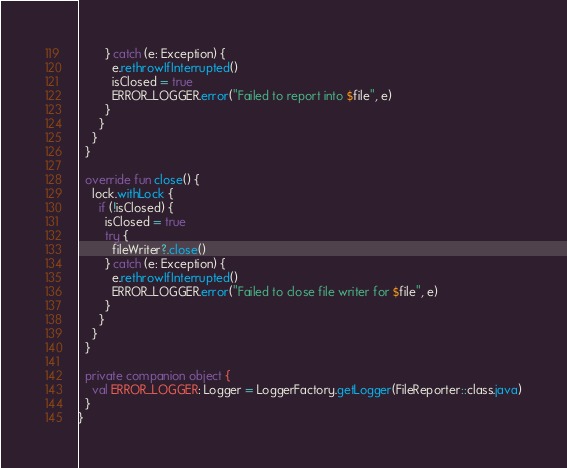<code> <loc_0><loc_0><loc_500><loc_500><_Kotlin_>        } catch (e: Exception) {
          e.rethrowIfInterrupted()
          isClosed = true
          ERROR_LOGGER.error("Failed to report into $file", e)
        }
      }
    }
  }

  override fun close() {
    lock.withLock {
      if (!isClosed) {
        isClosed = true
        try {
          fileWriter?.close()
        } catch (e: Exception) {
          e.rethrowIfInterrupted()
          ERROR_LOGGER.error("Failed to close file writer for $file", e)
        }
      }
    }
  }

  private companion object {
    val ERROR_LOGGER: Logger = LoggerFactory.getLogger(FileReporter::class.java)
  }
}</code> 